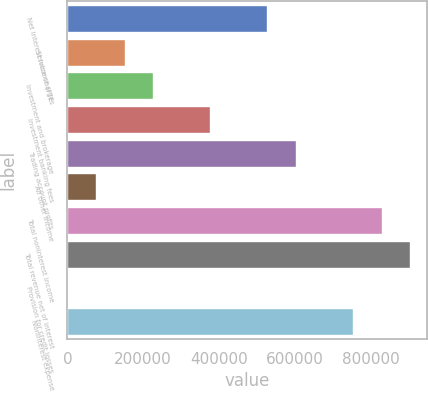Convert chart to OTSL. <chart><loc_0><loc_0><loc_500><loc_500><bar_chart><fcel>Net interest income (FTE<fcel>Service charges<fcel>Investment and brokerage<fcel>Investment banking fees<fcel>Trading account profits<fcel>All other income<fcel>Total noninterest income<fcel>Total revenue net of interest<fcel>Provision for credit losses<fcel>Noninterest expense<nl><fcel>527741<fcel>150902<fcel>226269<fcel>377005<fcel>603108<fcel>75533.8<fcel>829212<fcel>904580<fcel>166<fcel>753844<nl></chart> 